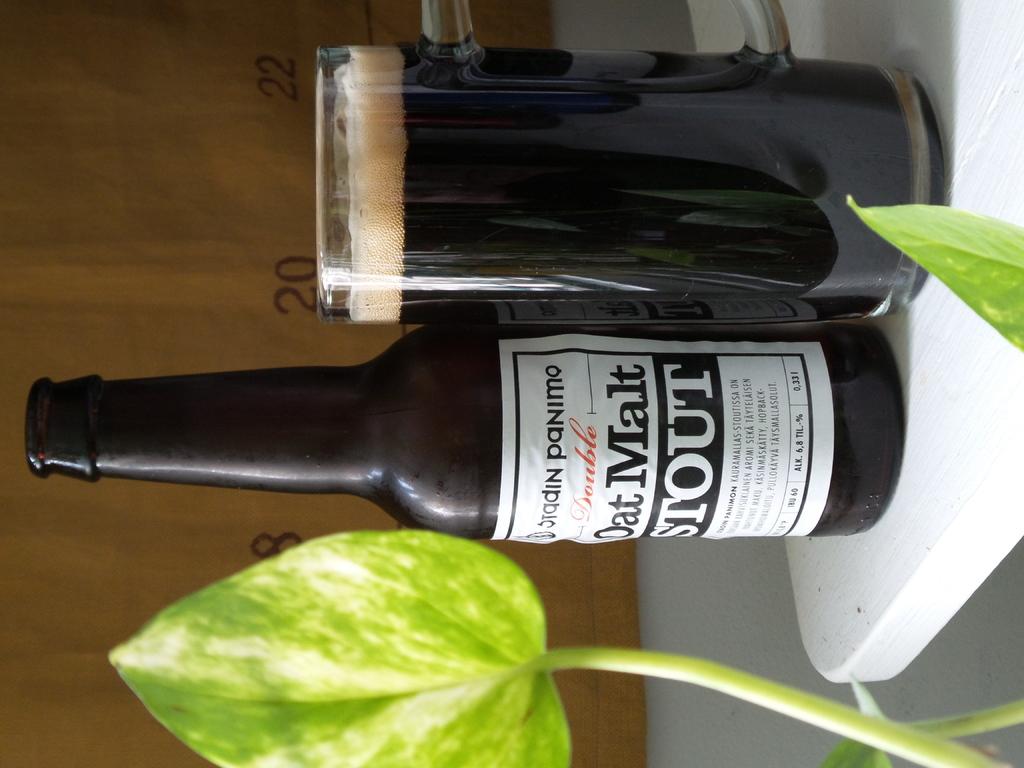What is the kind of drink being featured here?
Ensure brevity in your answer.  Stout. 